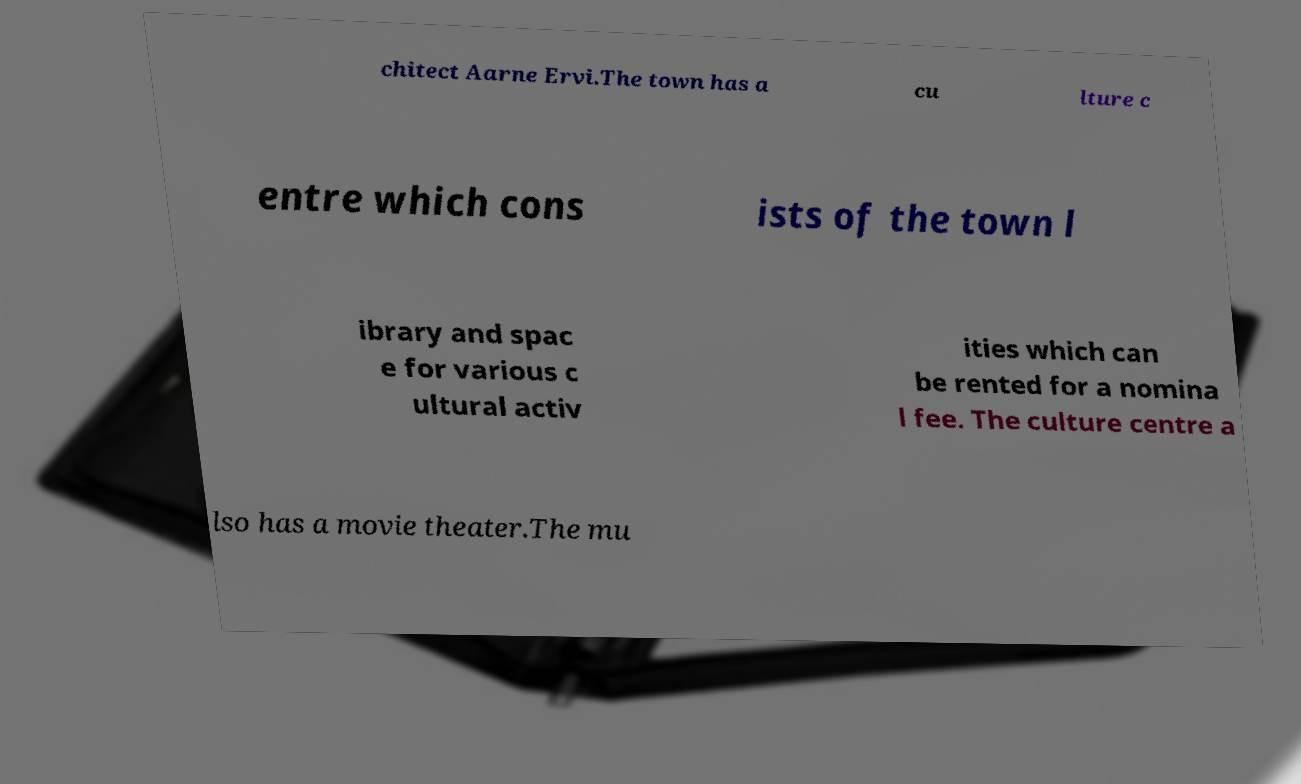Can you accurately transcribe the text from the provided image for me? chitect Aarne Ervi.The town has a cu lture c entre which cons ists of the town l ibrary and spac e for various c ultural activ ities which can be rented for a nomina l fee. The culture centre a lso has a movie theater.The mu 